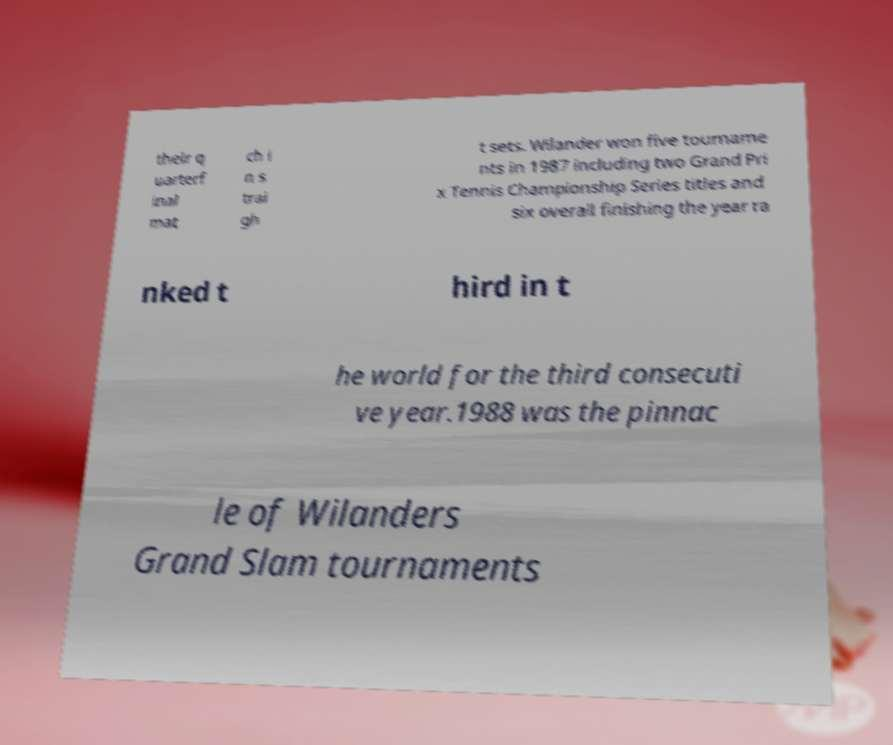Can you read and provide the text displayed in the image?This photo seems to have some interesting text. Can you extract and type it out for me? their q uarterf inal mat ch i n s trai gh t sets. Wilander won five tourname nts in 1987 including two Grand Pri x Tennis Championship Series titles and six overall finishing the year ra nked t hird in t he world for the third consecuti ve year.1988 was the pinnac le of Wilanders Grand Slam tournaments 